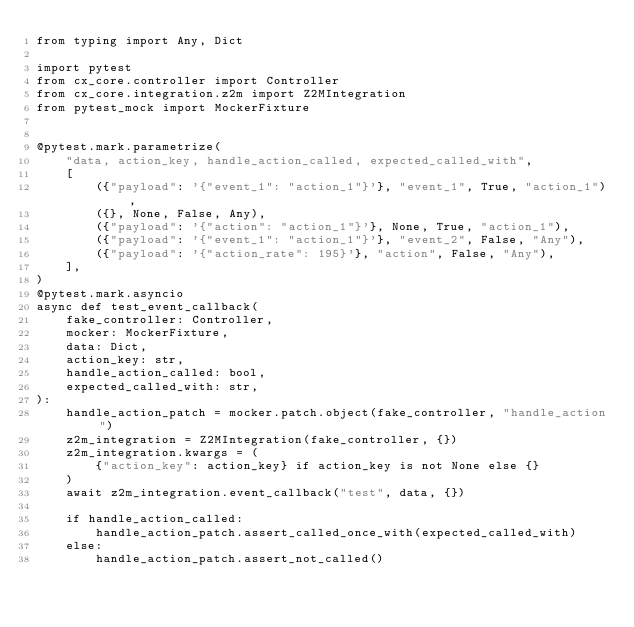Convert code to text. <code><loc_0><loc_0><loc_500><loc_500><_Python_>from typing import Any, Dict

import pytest
from cx_core.controller import Controller
from cx_core.integration.z2m import Z2MIntegration
from pytest_mock import MockerFixture


@pytest.mark.parametrize(
    "data, action_key, handle_action_called, expected_called_with",
    [
        ({"payload": '{"event_1": "action_1"}'}, "event_1", True, "action_1"),
        ({}, None, False, Any),
        ({"payload": '{"action": "action_1"}'}, None, True, "action_1"),
        ({"payload": '{"event_1": "action_1"}'}, "event_2", False, "Any"),
        ({"payload": '{"action_rate": 195}'}, "action", False, "Any"),
    ],
)
@pytest.mark.asyncio
async def test_event_callback(
    fake_controller: Controller,
    mocker: MockerFixture,
    data: Dict,
    action_key: str,
    handle_action_called: bool,
    expected_called_with: str,
):
    handle_action_patch = mocker.patch.object(fake_controller, "handle_action")
    z2m_integration = Z2MIntegration(fake_controller, {})
    z2m_integration.kwargs = (
        {"action_key": action_key} if action_key is not None else {}
    )
    await z2m_integration.event_callback("test", data, {})

    if handle_action_called:
        handle_action_patch.assert_called_once_with(expected_called_with)
    else:
        handle_action_patch.assert_not_called()
</code> 